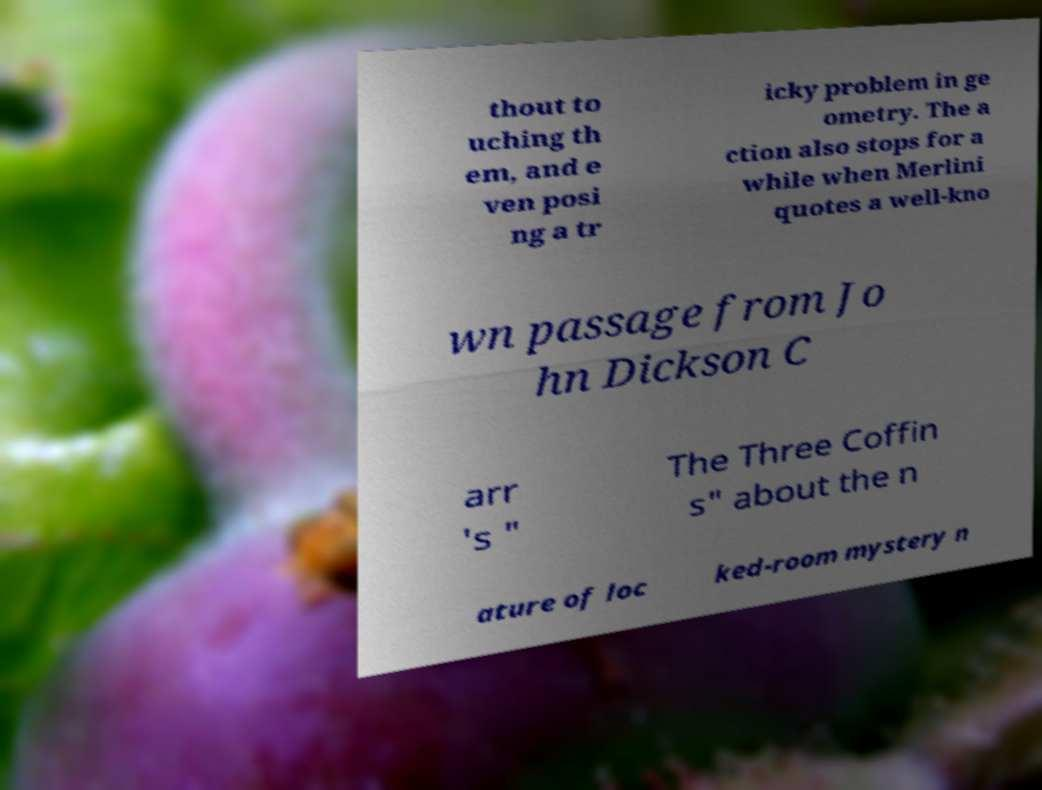What messages or text are displayed in this image? I need them in a readable, typed format. thout to uching th em, and e ven posi ng a tr icky problem in ge ometry. The a ction also stops for a while when Merlini quotes a well-kno wn passage from Jo hn Dickson C arr 's " The Three Coffin s" about the n ature of loc ked-room mystery n 